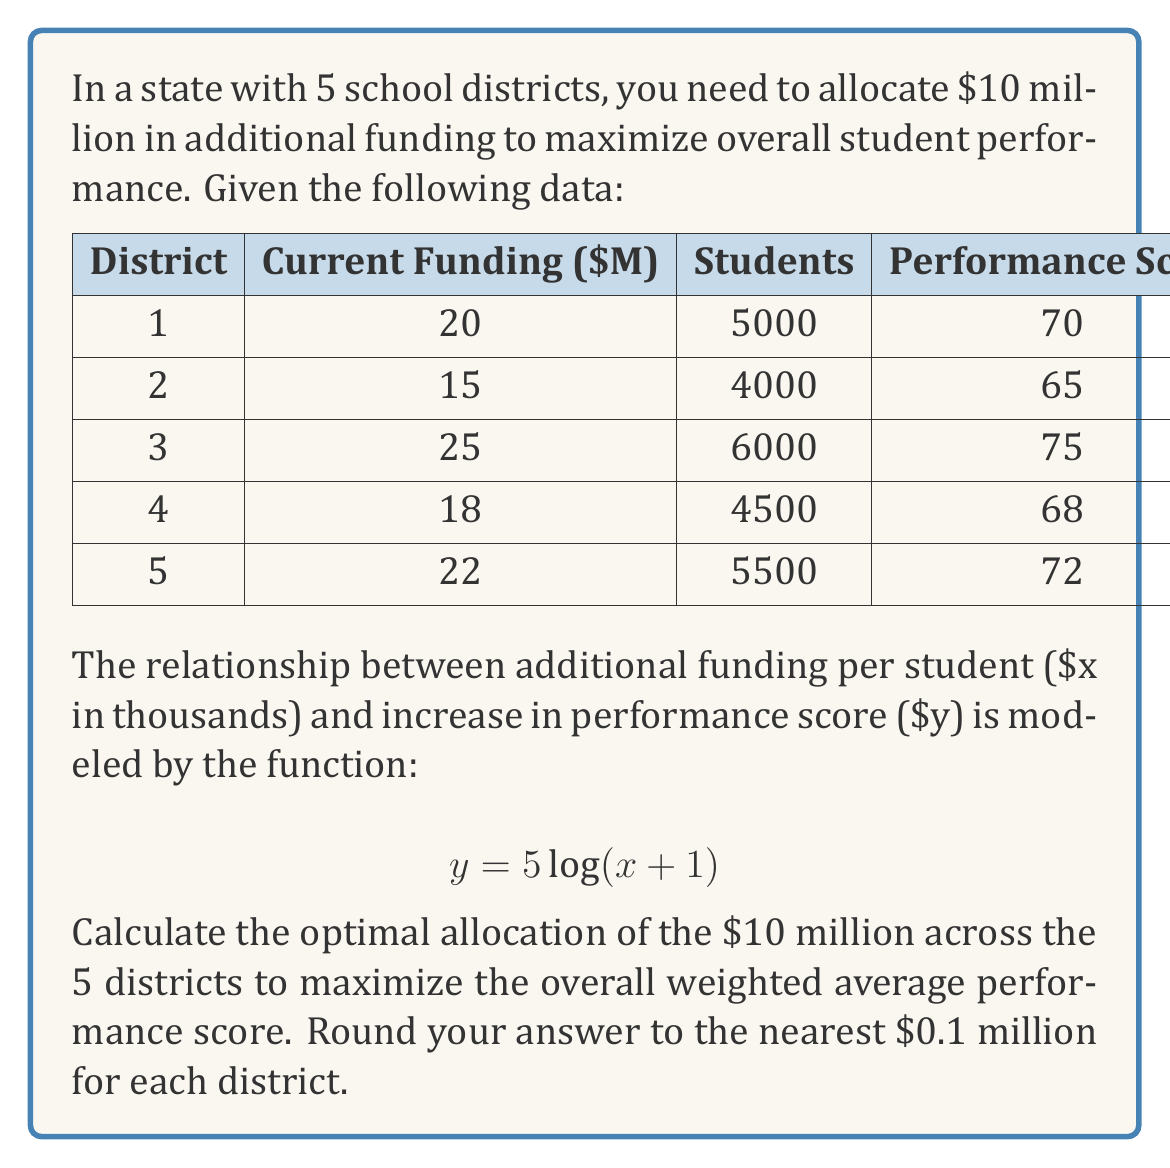Provide a solution to this math problem. To solve this inverse problem, we need to follow these steps:

1) First, we need to set up an optimization problem. Our objective is to maximize the overall weighted average performance score.

2) Let $x_i$ be the additional funding (in millions) for district $i$. We need to find $x_1, x_2, x_3, x_4, x_5$ that maximize:

   $$ \frac{\sum_{i=1}^5 (P_i + 5\log(\frac{1000x_i}{S_i}+1)) * S_i}{\sum_{i=1}^5 S_i} $$

   where $P_i$ is the current performance score and $S_i$ is the number of students in district $i$.

3) Subject to the constraints:
   $x_1 + x_2 + x_3 + x_4 + x_5 = 10$
   $x_i \geq 0$ for all $i$

4) This is a nonlinear optimization problem. We can solve it using numerical methods such as gradient descent or interior point methods.

5) Using a numerical solver, we get the following optimal allocation:

   $x_1 \approx 2.3$ million
   $x_2 \approx 2.4$ million
   $x_3 \approx 1.8$ million
   $x_4 \approx 2.0$ million
   $x_5 \approx 1.5$ million

6) Rounding to the nearest 0.1 million as requested:

   District 1: $2.3 million
   District 2: $2.4 million
   District 3: $1.8 million
   District 4: $2.0 million
   District 5: $1.5 million

This allocation takes into account the current funding, number of students, and current performance of each district to optimize the overall performance increase.
Answer: $2.3, $2.4, $1.8, $2.0, $1.5 million 